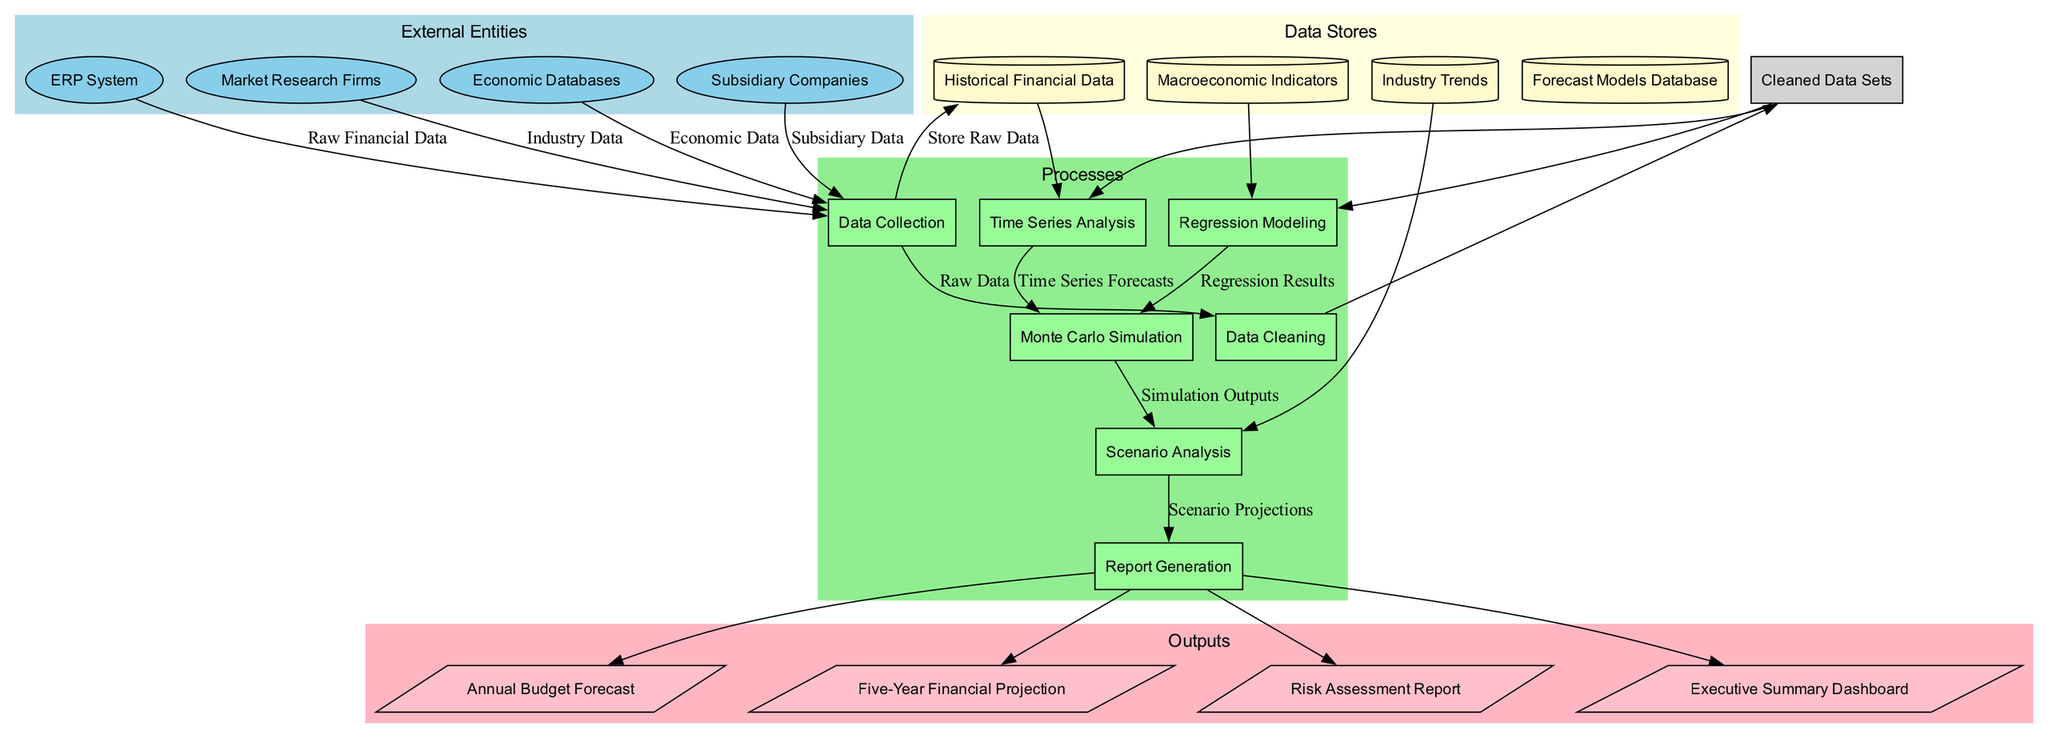What are the external entities involved in this process? The diagram lists four external entities that feed data into the financial forecasting process: ERP System, Market Research Firms, Economic Databases, and Subsidiary Companies.
Answer: ERP System, Market Research Firms, Economic Databases, Subsidiary Companies How many processes are there in the diagram? The diagram includes seven distinct processes: Data Collection, Data Cleaning, Time Series Analysis, Regression Modeling, Monte Carlo Simulation, Scenario Analysis, and Report Generation. Counting these processes gives a total of seven.
Answer: 7 What is the output generated from the Report Generation process? The Report Generation process leads to four outputs: Annual Budget Forecast, Five-Year Financial Projection, Risk Assessment Report, and Executive Summary Dashboard. Therefore, the outputs are the four documents that are generated from this process.
Answer: Annual Budget Forecast, Five-Year Financial Projection, Risk Assessment Report, Executive Summary Dashboard Which data store is used for Time Series Analysis? The Time Series Analysis process directly uses inputs from the Historical Financial Data data store, as shown in the diagram connections.
Answer: Historical Financial Data What data flow connects the Data Collection process to the Data Cleaning process? The Data Collection process outputs Raw Data, which is the data flow that connects it to the Data Cleaning process. This indicates that the raw data collected is then cleaned in the next step.
Answer: Raw Data In which process does Monte Carlo Simulation rely on inputs from Regression Modeling? The Monte Carlo Simulation process uses Regression Results as an input sourced from the preceding Regression Modeling process. This shows how simulation methods integrate regression analysis outputs.
Answer: Regression Results What type of analysis follows the Monte Carlo Simulation process? After completing the Monte Carlo Simulation, the next step is Scenario Analysis, which utilizes the outputs from the simulation process to project different scenarios.
Answer: Scenario Analysis How many data stores are present in this diagram? The diagram lists four data stores: Historical Financial Data, Macroeconomic Indicators, Industry Trends, and Forecast Models Database. Counting these provides the total number of data stores.
Answer: 4 